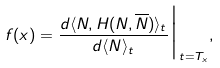Convert formula to latex. <formula><loc_0><loc_0><loc_500><loc_500>f ( x ) = \frac { d \langle N , H ( N , \overline { N } ) \rangle _ { t } } { d \langle N \rangle _ { t } } \Big | _ { t = T _ { x } } ,</formula> 